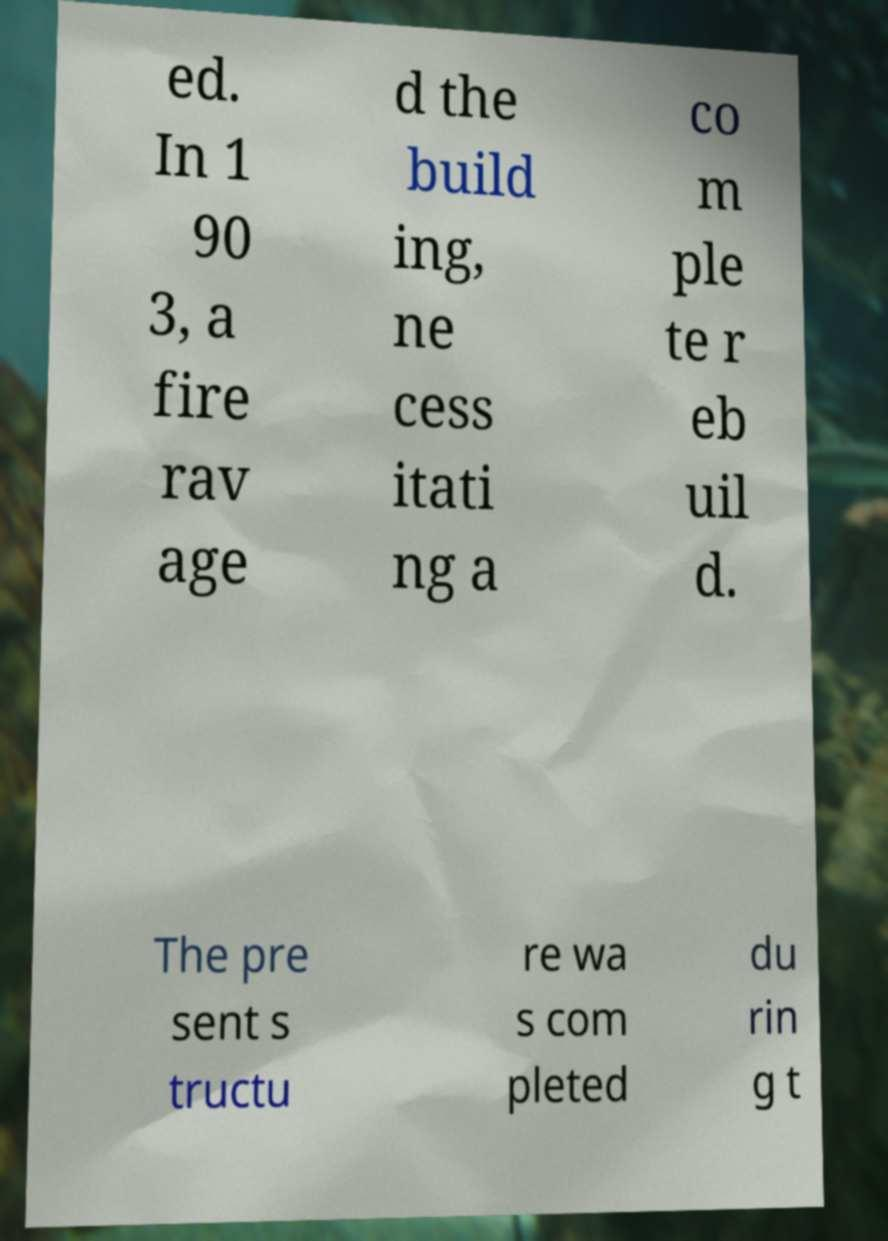Can you read and provide the text displayed in the image?This photo seems to have some interesting text. Can you extract and type it out for me? ed. In 1 90 3, a fire rav age d the build ing, ne cess itati ng a co m ple te r eb uil d. The pre sent s tructu re wa s com pleted du rin g t 